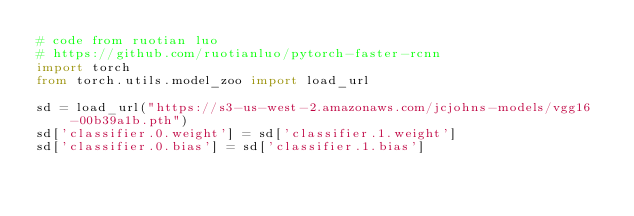<code> <loc_0><loc_0><loc_500><loc_500><_Python_># code from ruotian luo
# https://github.com/ruotianluo/pytorch-faster-rcnn
import torch
from torch.utils.model_zoo import load_url

sd = load_url("https://s3-us-west-2.amazonaws.com/jcjohns-models/vgg16-00b39a1b.pth")
sd['classifier.0.weight'] = sd['classifier.1.weight']
sd['classifier.0.bias'] = sd['classifier.1.bias']</code> 